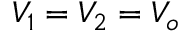Convert formula to latex. <formula><loc_0><loc_0><loc_500><loc_500>V _ { 1 } = V _ { 2 } = V _ { o }</formula> 